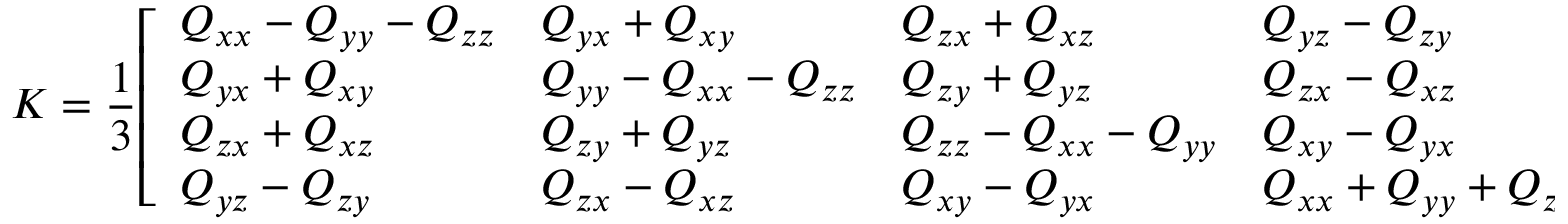Convert formula to latex. <formula><loc_0><loc_0><loc_500><loc_500>K = { \frac { 1 } { 3 } } { \left [ \begin{array} { l l l l } { Q _ { x x } - Q _ { y y } - Q _ { z z } } & { Q _ { y x } + Q _ { x y } } & { Q _ { z x } + Q _ { x z } } & { Q _ { y z } - Q _ { z y } } \\ { Q _ { y x } + Q _ { x y } } & { Q _ { y y } - Q _ { x x } - Q _ { z z } } & { Q _ { z y } + Q _ { y z } } & { Q _ { z x } - Q _ { x z } } \\ { Q _ { z x } + Q _ { x z } } & { Q _ { z y } + Q _ { y z } } & { Q _ { z z } - Q _ { x x } - Q _ { y y } } & { Q _ { x y } - Q _ { y x } } \\ { Q _ { y z } - Q _ { z y } } & { Q _ { z x } - Q _ { x z } } & { Q _ { x y } - Q _ { y x } } & { Q _ { x x } + Q _ { y y } + Q _ { z z } } \end{array} \right ] } ,</formula> 